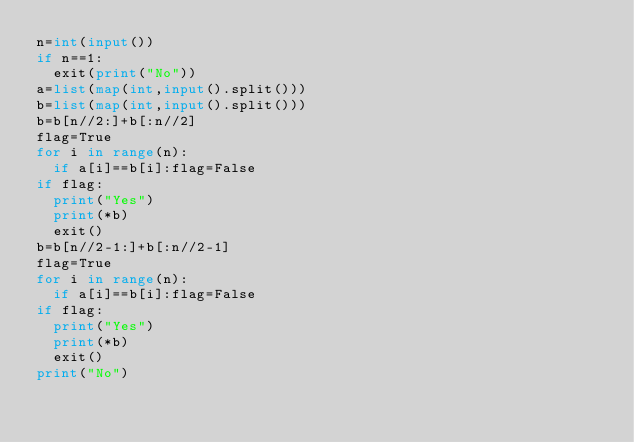<code> <loc_0><loc_0><loc_500><loc_500><_Python_>n=int(input())
if n==1:
  exit(print("No"))
a=list(map(int,input().split()))
b=list(map(int,input().split()))
b=b[n//2:]+b[:n//2]
flag=True
for i in range(n):
  if a[i]==b[i]:flag=False
if flag:
  print("Yes")
  print(*b)
  exit()
b=b[n//2-1:]+b[:n//2-1]
flag=True
for i in range(n):
  if a[i]==b[i]:flag=False
if flag:
  print("Yes")
  print(*b)
  exit()
print("No")</code> 